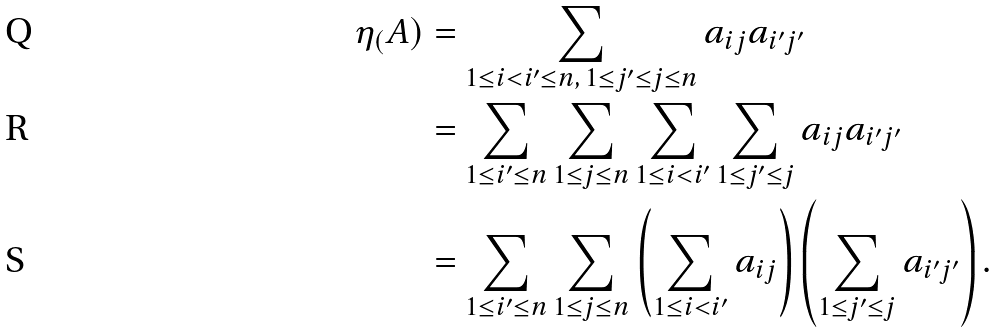<formula> <loc_0><loc_0><loc_500><loc_500>\eta _ { ( } A ) & = \sum _ { 1 \leq i < i ^ { \prime } \leq n , \, 1 \leq j ^ { \prime } \leq j \leq n } a _ { i j } a _ { i ^ { \prime } j ^ { \prime } } \\ & = \sum _ { 1 \leq i ^ { \prime } \leq n } \sum _ { 1 \leq j \leq n } \sum _ { 1 \leq i < i ^ { \prime } } \sum _ { 1 \leq j ^ { \prime } \leq j } a _ { i j } a _ { i ^ { \prime } j ^ { \prime } } \\ & = \sum _ { 1 \leq i ^ { \prime } \leq n } \sum _ { 1 \leq j \leq n } \left ( \sum _ { 1 \leq i < i ^ { \prime } } a _ { i j } \right ) \left ( \sum _ { 1 \leq j ^ { \prime } \leq j } a _ { i ^ { \prime } j ^ { \prime } } \right ) .</formula> 